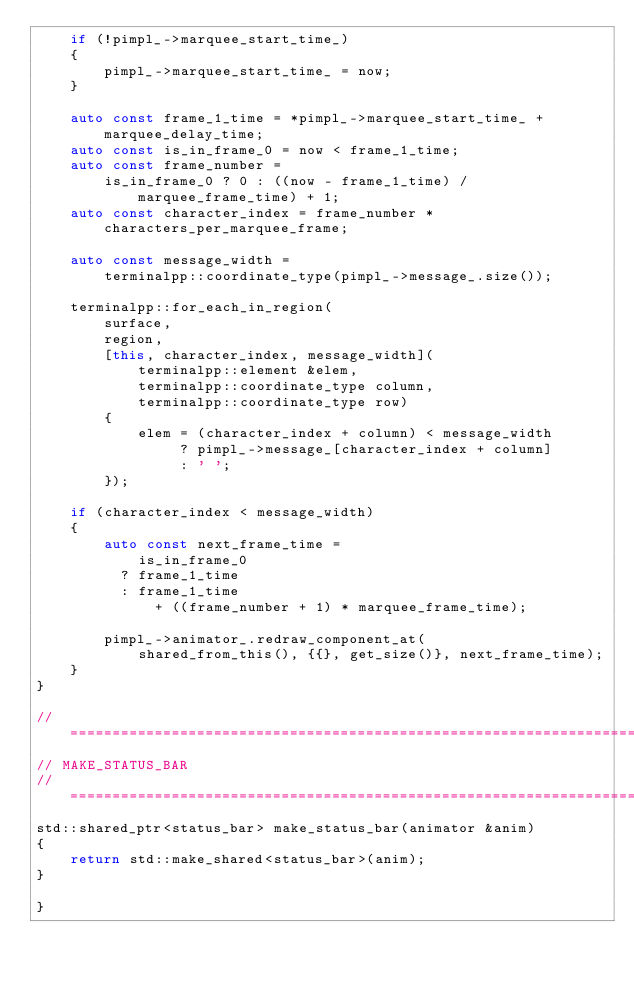Convert code to text. <code><loc_0><loc_0><loc_500><loc_500><_C++_>    if (!pimpl_->marquee_start_time_)
    {
        pimpl_->marquee_start_time_ = now;
    }

    auto const frame_1_time = *pimpl_->marquee_start_time_ + marquee_delay_time;
    auto const is_in_frame_0 = now < frame_1_time;
    auto const frame_number = 
        is_in_frame_0 ? 0 : ((now - frame_1_time) / marquee_frame_time) + 1;
    auto const character_index = frame_number * characters_per_marquee_frame;

    auto const message_width = 
        terminalpp::coordinate_type(pimpl_->message_.size());

    terminalpp::for_each_in_region(
        surface,
        region,
        [this, character_index, message_width](
            terminalpp::element &elem,
            terminalpp::coordinate_type column,
            terminalpp::coordinate_type row)
        {
            elem = (character_index + column) < message_width
                 ? pimpl_->message_[character_index + column]
                 : ' ';
        });

    if (character_index < message_width)
    {
        auto const next_frame_time =
            is_in_frame_0
          ? frame_1_time
          : frame_1_time
              + ((frame_number + 1) * marquee_frame_time);
        
        pimpl_->animator_.redraw_component_at(
            shared_from_this(), {{}, get_size()}, next_frame_time);
    }
}

// ==========================================================================
// MAKE_STATUS_BAR
// ==========================================================================
std::shared_ptr<status_bar> make_status_bar(animator &anim)
{
    return std::make_shared<status_bar>(anim);
}

}
</code> 